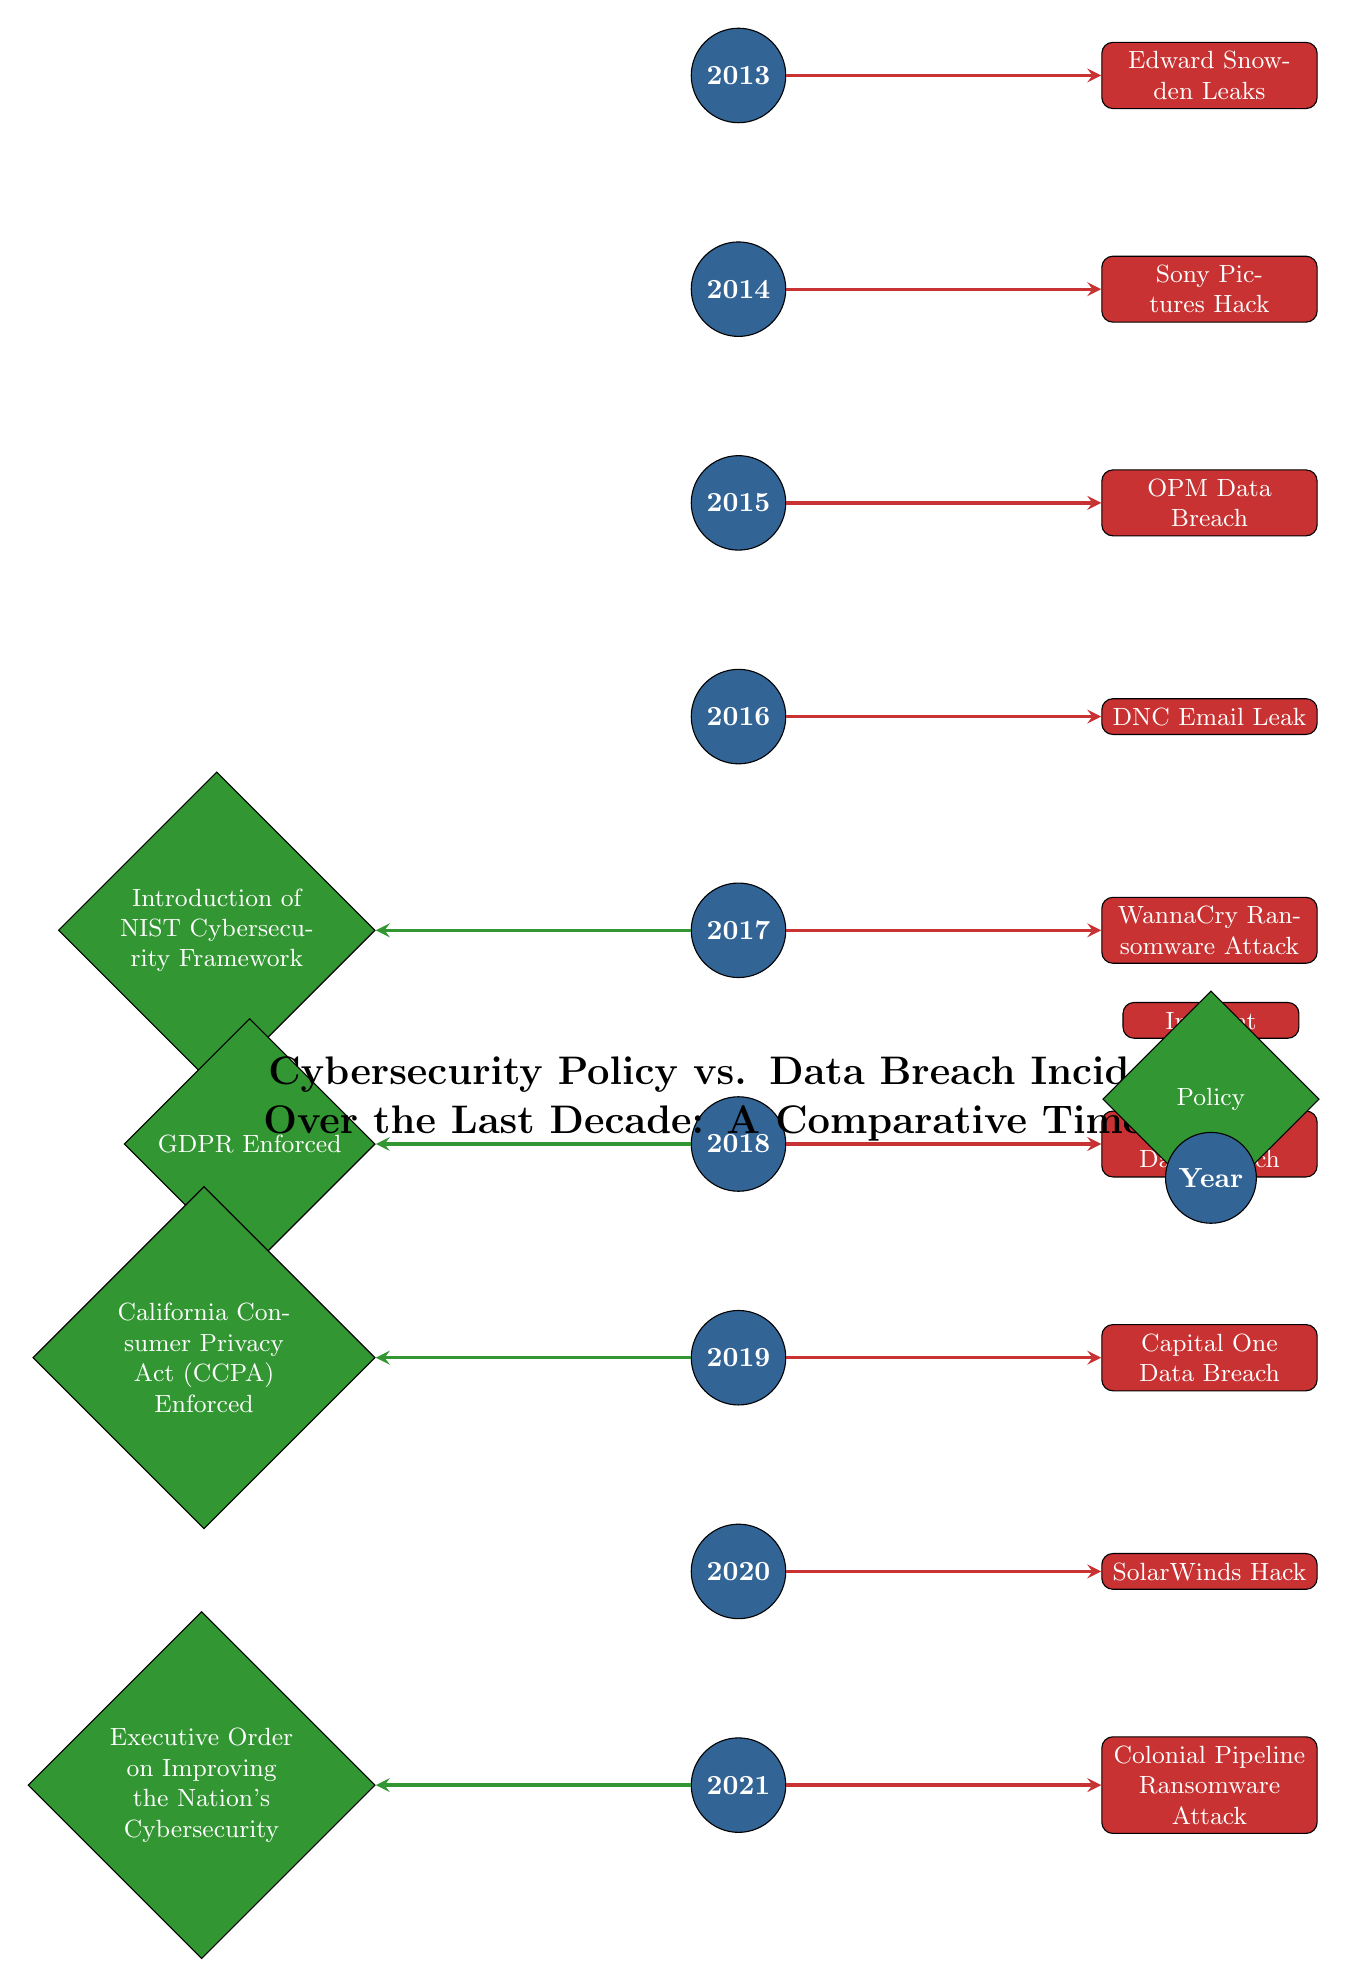What incident occurred in 2018? The diagram shows that the incident for 2018 is the "Marriott Data Breach," which is represented as a rectangle next to the year 2018 in the diagram.
Answer: Marriott Data Breach How many major incidents are shown in the diagram? By counting the rectangles labeled as incidents to the right of each year, there are nine distinct incidents presented, from 2013 to 2021.
Answer: 9 Which year is associated with the introduction of the NIST Cybersecurity Framework? The diagram places the "Introduction of NIST Cybersecurity Framework" diamond shape to the left of the year 2017, indicating that this policy was introduced in that year.
Answer: 2017 Name the incident that occurred immediately after the enforcement of GDPR. According to the diagram, GDPR was enforced in 2018, and the incident that follows in the timeline is the "Marriott Data Breach" occurring in the same year, highlighting the close timing of events.
Answer: Marriott Data Breach What is the relationship between the Executive Order on Improving the Nation's Cybersecurity and the Colonial Pipeline Ransomware Attack? The diagram shows that the Executive Order on Cybersecurity was introduced in 2021, the same year as the Colonial Pipeline Ransomware Attack, illustrating a simultaneous occurrence without direct impact information.
Answer: Same year What incident directly followed the WannaCry Ransomware Attack? The timeline indicates that after the "WannaCry Ransomware Attack" in 2017, the next recorded incident is the "Marriott Data Breach" in 2018, as shown in the sequence of incidents.
Answer: Marriott Data Breach Which policy was enforced prior to the California Consumer Privacy Act? Based on the diagram, the policy enforced before the California Consumer Privacy Act in 2019 is the GDPR, which was enforced in 2018 according to its placement to the left of 2019.
Answer: GDPR How many policies are marked in the diagram? The diagram shows four policies marked as diamond shapes (NIST, GDPR, CCPA, and Executive Order), corresponding to the years they were introduced or enforced.
Answer: 4 What is the main focus of the title of the diagram? The title indicates a comparative study between "Cybersecurity Policy" and "Data Breach Incidents," highlighting a relationship between policy changes and their resulting impacts on incidents over the decade.
Answer: Comparative study 